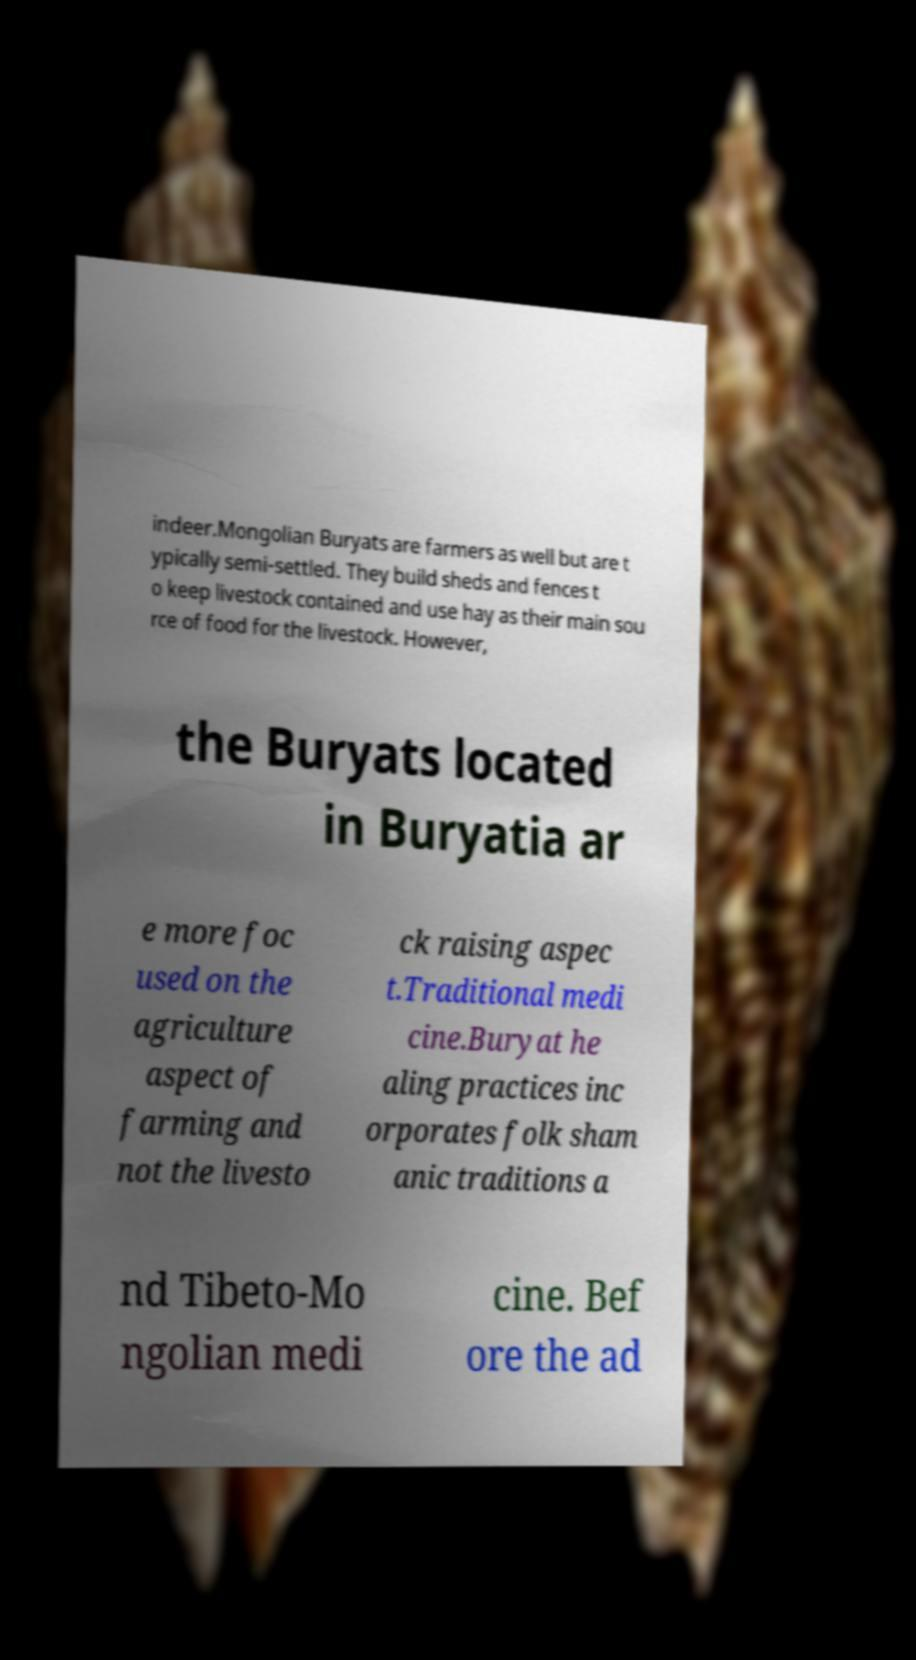I need the written content from this picture converted into text. Can you do that? indeer.Mongolian Buryats are farmers as well but are t ypically semi-settled. They build sheds and fences t o keep livestock contained and use hay as their main sou rce of food for the livestock. However, the Buryats located in Buryatia ar e more foc used on the agriculture aspect of farming and not the livesto ck raising aspec t.Traditional medi cine.Buryat he aling practices inc orporates folk sham anic traditions a nd Tibeto-Mo ngolian medi cine. Bef ore the ad 